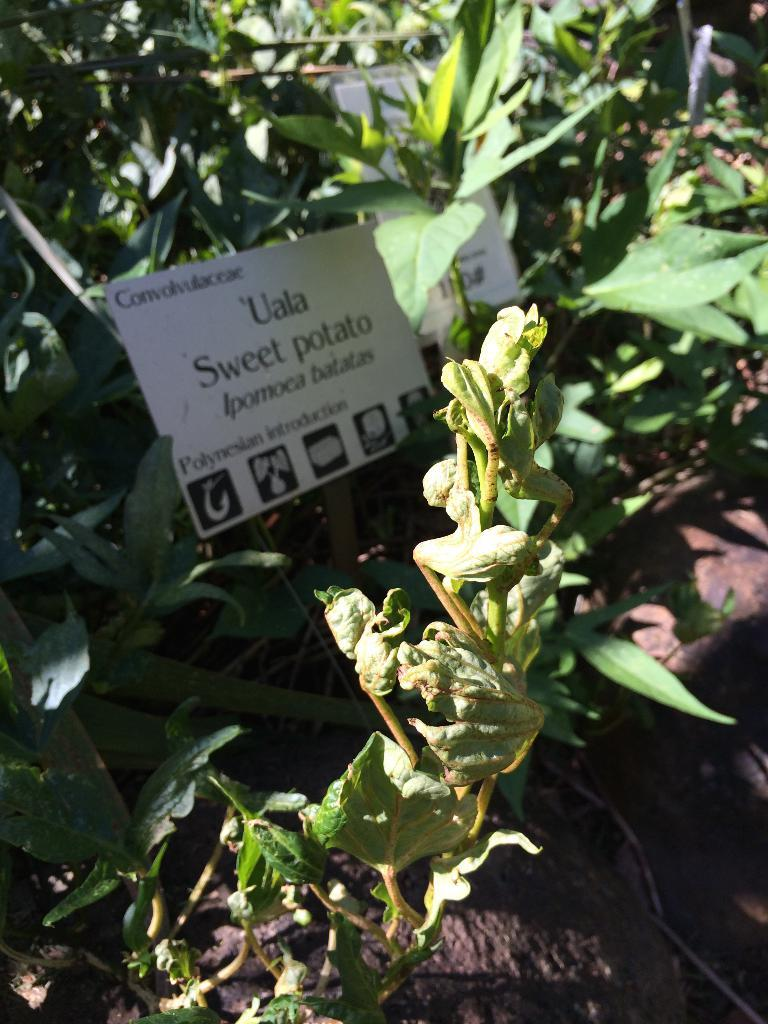What is located in the center of the image? There are plants in the center of the image. What object is present in the image that might be used for displaying information? There is a board in the image with text on it. What type of material can be seen at the bottom of the image? There are rocks at the bottom of the image. What other object can be seen in the image? There is a pipe in the image. What type of store can be seen in the image? There is no store present in the image. What form does the pipe take in the image? The pipe is a linear object in the image, but it does not have a specific form beyond that. 